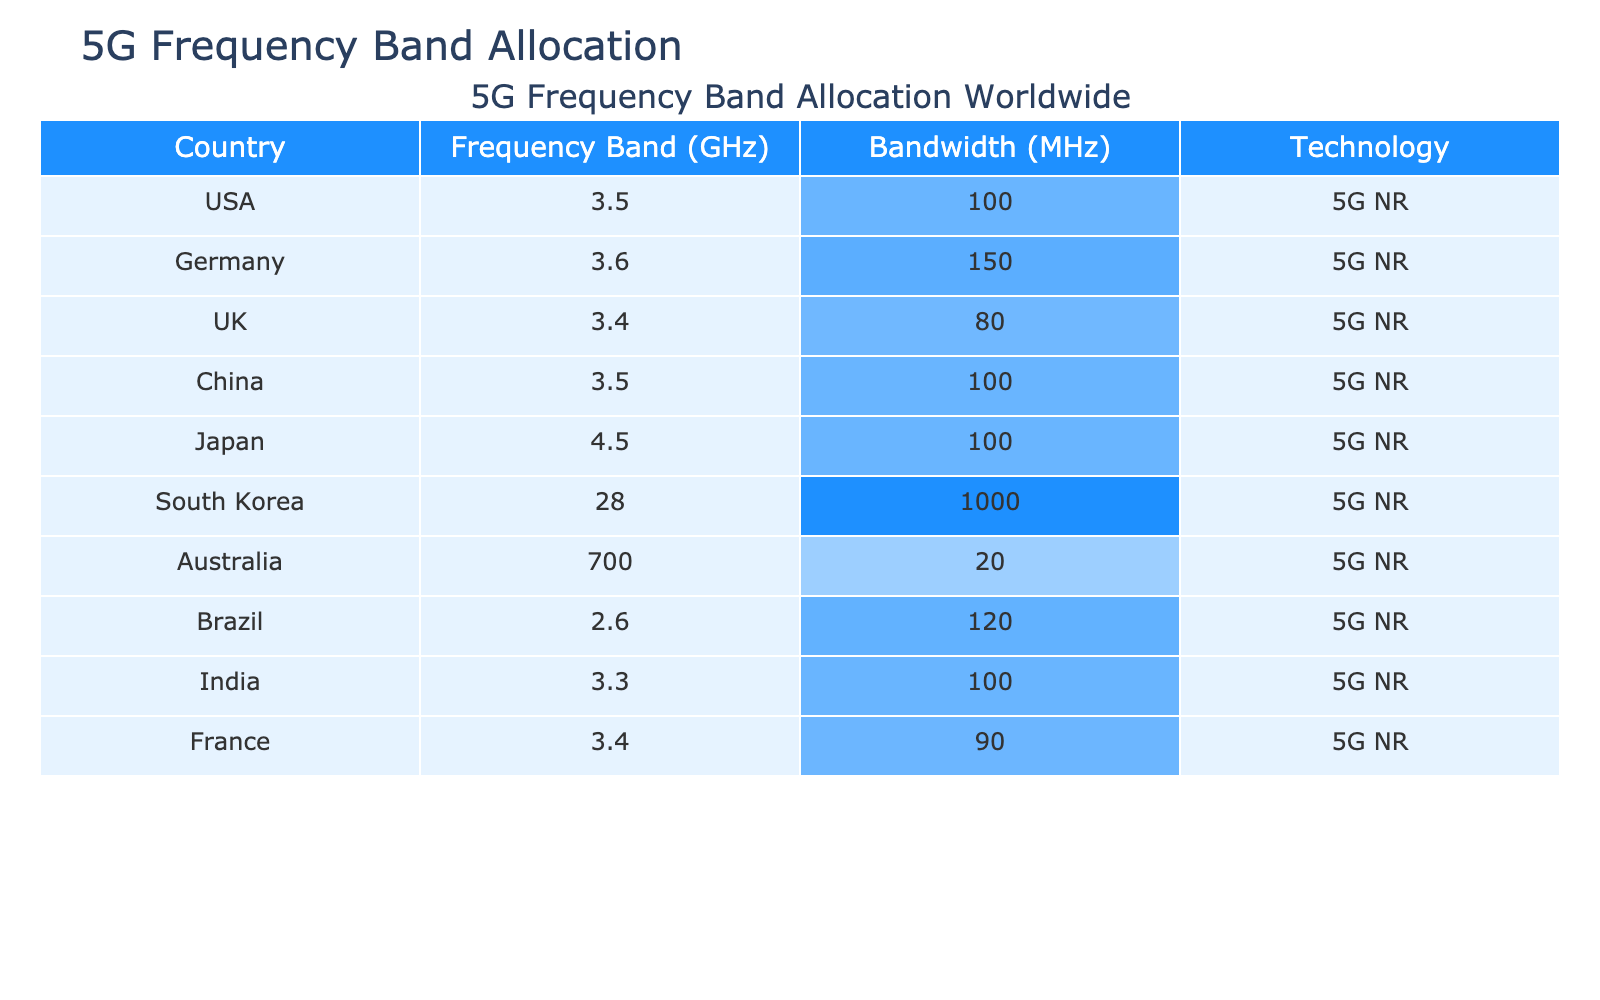What is the frequency band allocated to South Korea? Referring to the table, the specific frequency band allocated to South Korea is listed as 28 GHz.
Answer: 28 GHz Which country has the highest bandwidth allocated in the table? In the table, South Korea has the highest bandwidth of 1000 MHz, which is greater than any other country listed.
Answer: South Korea What is the average bandwidth allocated for all countries listed? To find the average, we sum the bandwidths: (100 + 150 + 80 + 100 + 100 + 1000 + 20 + 120 + 100 + 90) = 1960 MHz. There are 10 countries, so the average is 1960/10 = 196 MHz.
Answer: 196 MHz Is the frequency band for the USA lower than that of India? The frequency for the USA is 3.5 GHz, while for India it is 3.3 GHz. Since 3.5 is greater than 3.3, the statement is false.
Answer: No How many countries have a frequency band of 3.5 GHz? By examining the table, both the USA and China have a frequency band of 3.5 GHz. Therefore, there are 2 countries with this frequency band.
Answer: 2 What is the total bandwidth allocated for countries with a frequency band greater than 3 GHz? The countries with a frequency band greater than 3 GHz are South Korea, Japan, Germany, and China. Their respective bandwidths are 1000, 100, 150, and 100 MHz. Adding these gives us 1000 + 100 + 150 + 100 = 1350 MHz.
Answer: 1350 MHz Which country has a frequency band closest to 3.4 GHz? The countries with frequency bands closest to 3.4 GHz are the UK (3.4 GHz) and France (3.4 GHz), both of which are the same frequency.
Answer: UK and France What is the difference in bandwidth between the country with the highest bandwidth and the country with the lowest bandwidth? The country with the highest bandwidth is South Korea with 1000 MHz, and the country with the lowest is Australia with 20 MHz. The difference is calculated as 1000 - 20 = 980 MHz.
Answer: 980 MHz 